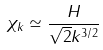<formula> <loc_0><loc_0><loc_500><loc_500>\chi _ { k } \simeq \frac { H } { \sqrt { 2 } k ^ { 3 / 2 } }</formula> 